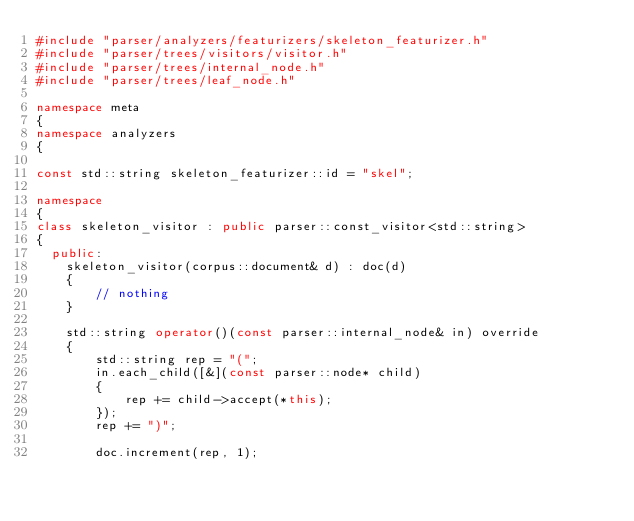<code> <loc_0><loc_0><loc_500><loc_500><_C++_>#include "parser/analyzers/featurizers/skeleton_featurizer.h"
#include "parser/trees/visitors/visitor.h"
#include "parser/trees/internal_node.h"
#include "parser/trees/leaf_node.h"

namespace meta
{
namespace analyzers
{

const std::string skeleton_featurizer::id = "skel";

namespace
{
class skeleton_visitor : public parser::const_visitor<std::string>
{
  public:
    skeleton_visitor(corpus::document& d) : doc(d)
    {
        // nothing
    }

    std::string operator()(const parser::internal_node& in) override
    {
        std::string rep = "(";
        in.each_child([&](const parser::node* child)
        {
            rep += child->accept(*this);
        });
        rep += ")";

        doc.increment(rep, 1);</code> 